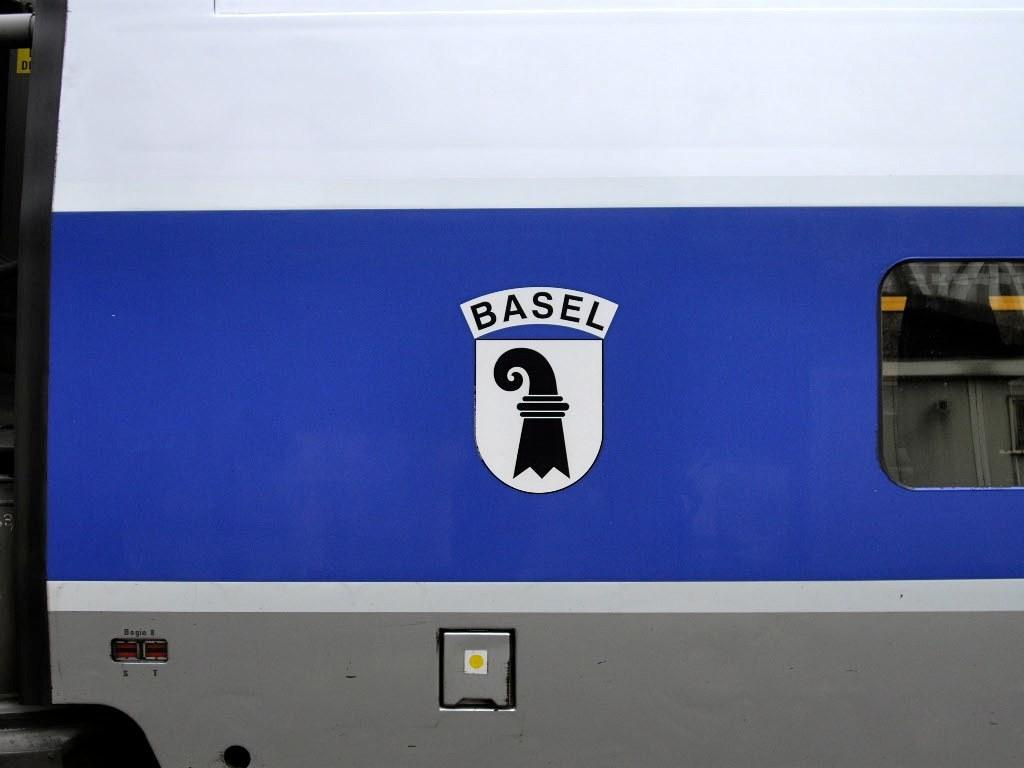What type of image is depicted in the picture? The image is a logo. Where is the logo located? The logo is on a vehicle. How does the logo compare to other logos in terms of crime prevention? The image does not provide any information about crime prevention or the effectiveness of the logo in comparison to other logos. 